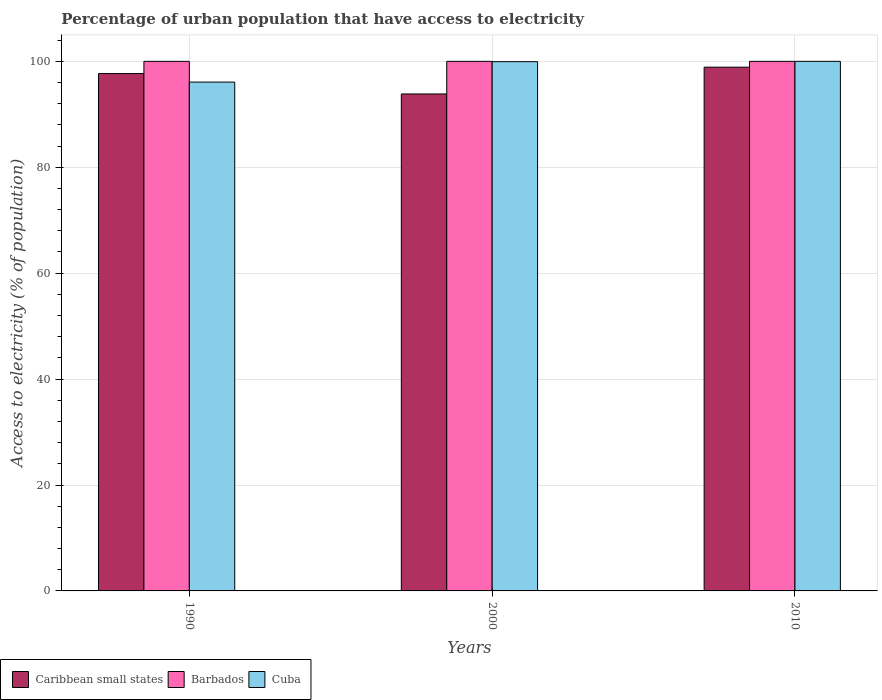How many different coloured bars are there?
Give a very brief answer. 3. Are the number of bars on each tick of the X-axis equal?
Your response must be concise. Yes. How many bars are there on the 1st tick from the left?
Offer a very short reply. 3. What is the label of the 2nd group of bars from the left?
Your response must be concise. 2000. In how many cases, is the number of bars for a given year not equal to the number of legend labels?
Give a very brief answer. 0. What is the percentage of urban population that have access to electricity in Caribbean small states in 2010?
Keep it short and to the point. 98.9. Across all years, what is the maximum percentage of urban population that have access to electricity in Barbados?
Provide a succinct answer. 100. Across all years, what is the minimum percentage of urban population that have access to electricity in Caribbean small states?
Your answer should be very brief. 93.84. In which year was the percentage of urban population that have access to electricity in Caribbean small states maximum?
Give a very brief answer. 2010. What is the total percentage of urban population that have access to electricity in Caribbean small states in the graph?
Provide a succinct answer. 290.44. What is the difference between the percentage of urban population that have access to electricity in Caribbean small states in 2000 and that in 2010?
Ensure brevity in your answer.  -5.06. What is the difference between the percentage of urban population that have access to electricity in Cuba in 2000 and the percentage of urban population that have access to electricity in Caribbean small states in 1990?
Provide a short and direct response. 2.24. What is the average percentage of urban population that have access to electricity in Barbados per year?
Give a very brief answer. 100. In the year 1990, what is the difference between the percentage of urban population that have access to electricity in Barbados and percentage of urban population that have access to electricity in Caribbean small states?
Offer a terse response. 2.3. In how many years, is the percentage of urban population that have access to electricity in Caribbean small states greater than 36 %?
Offer a very short reply. 3. What is the ratio of the percentage of urban population that have access to electricity in Barbados in 1990 to that in 2000?
Your response must be concise. 1. Is the percentage of urban population that have access to electricity in Caribbean small states in 1990 less than that in 2000?
Your answer should be very brief. No. What is the difference between the highest and the second highest percentage of urban population that have access to electricity in Cuba?
Provide a succinct answer. 0.06. What is the difference between the highest and the lowest percentage of urban population that have access to electricity in Cuba?
Offer a terse response. 3.91. In how many years, is the percentage of urban population that have access to electricity in Cuba greater than the average percentage of urban population that have access to electricity in Cuba taken over all years?
Ensure brevity in your answer.  2. Is the sum of the percentage of urban population that have access to electricity in Caribbean small states in 2000 and 2010 greater than the maximum percentage of urban population that have access to electricity in Barbados across all years?
Make the answer very short. Yes. What does the 2nd bar from the left in 2000 represents?
Offer a terse response. Barbados. What does the 3rd bar from the right in 2000 represents?
Your response must be concise. Caribbean small states. Is it the case that in every year, the sum of the percentage of urban population that have access to electricity in Barbados and percentage of urban population that have access to electricity in Caribbean small states is greater than the percentage of urban population that have access to electricity in Cuba?
Your answer should be compact. Yes. How many bars are there?
Offer a very short reply. 9. How many years are there in the graph?
Provide a succinct answer. 3. Does the graph contain any zero values?
Keep it short and to the point. No. Where does the legend appear in the graph?
Your response must be concise. Bottom left. What is the title of the graph?
Your answer should be compact. Percentage of urban population that have access to electricity. What is the label or title of the Y-axis?
Keep it short and to the point. Access to electricity (% of population). What is the Access to electricity (% of population) of Caribbean small states in 1990?
Provide a succinct answer. 97.7. What is the Access to electricity (% of population) in Cuba in 1990?
Your answer should be very brief. 96.09. What is the Access to electricity (% of population) of Caribbean small states in 2000?
Your answer should be compact. 93.84. What is the Access to electricity (% of population) in Barbados in 2000?
Your answer should be compact. 100. What is the Access to electricity (% of population) of Cuba in 2000?
Make the answer very short. 99.94. What is the Access to electricity (% of population) in Caribbean small states in 2010?
Your answer should be very brief. 98.9. What is the Access to electricity (% of population) in Barbados in 2010?
Give a very brief answer. 100. What is the Access to electricity (% of population) in Cuba in 2010?
Keep it short and to the point. 100. Across all years, what is the maximum Access to electricity (% of population) of Caribbean small states?
Ensure brevity in your answer.  98.9. Across all years, what is the maximum Access to electricity (% of population) of Cuba?
Ensure brevity in your answer.  100. Across all years, what is the minimum Access to electricity (% of population) of Caribbean small states?
Give a very brief answer. 93.84. Across all years, what is the minimum Access to electricity (% of population) in Cuba?
Provide a succinct answer. 96.09. What is the total Access to electricity (% of population) in Caribbean small states in the graph?
Make the answer very short. 290.44. What is the total Access to electricity (% of population) of Barbados in the graph?
Your response must be concise. 300. What is the total Access to electricity (% of population) in Cuba in the graph?
Your answer should be very brief. 296.02. What is the difference between the Access to electricity (% of population) in Caribbean small states in 1990 and that in 2000?
Ensure brevity in your answer.  3.85. What is the difference between the Access to electricity (% of population) in Cuba in 1990 and that in 2000?
Ensure brevity in your answer.  -3.85. What is the difference between the Access to electricity (% of population) in Caribbean small states in 1990 and that in 2010?
Your answer should be very brief. -1.2. What is the difference between the Access to electricity (% of population) in Barbados in 1990 and that in 2010?
Give a very brief answer. 0. What is the difference between the Access to electricity (% of population) in Cuba in 1990 and that in 2010?
Provide a succinct answer. -3.91. What is the difference between the Access to electricity (% of population) in Caribbean small states in 2000 and that in 2010?
Ensure brevity in your answer.  -5.06. What is the difference between the Access to electricity (% of population) in Cuba in 2000 and that in 2010?
Provide a succinct answer. -0.06. What is the difference between the Access to electricity (% of population) of Caribbean small states in 1990 and the Access to electricity (% of population) of Barbados in 2000?
Offer a very short reply. -2.3. What is the difference between the Access to electricity (% of population) in Caribbean small states in 1990 and the Access to electricity (% of population) in Cuba in 2000?
Offer a very short reply. -2.24. What is the difference between the Access to electricity (% of population) in Barbados in 1990 and the Access to electricity (% of population) in Cuba in 2000?
Ensure brevity in your answer.  0.06. What is the difference between the Access to electricity (% of population) in Caribbean small states in 1990 and the Access to electricity (% of population) in Barbados in 2010?
Ensure brevity in your answer.  -2.3. What is the difference between the Access to electricity (% of population) in Caribbean small states in 1990 and the Access to electricity (% of population) in Cuba in 2010?
Make the answer very short. -2.3. What is the difference between the Access to electricity (% of population) in Caribbean small states in 2000 and the Access to electricity (% of population) in Barbados in 2010?
Make the answer very short. -6.16. What is the difference between the Access to electricity (% of population) in Caribbean small states in 2000 and the Access to electricity (% of population) in Cuba in 2010?
Offer a terse response. -6.16. What is the average Access to electricity (% of population) of Caribbean small states per year?
Your response must be concise. 96.81. What is the average Access to electricity (% of population) of Barbados per year?
Ensure brevity in your answer.  100. What is the average Access to electricity (% of population) in Cuba per year?
Provide a succinct answer. 98.67. In the year 1990, what is the difference between the Access to electricity (% of population) in Caribbean small states and Access to electricity (% of population) in Barbados?
Keep it short and to the point. -2.3. In the year 1990, what is the difference between the Access to electricity (% of population) of Caribbean small states and Access to electricity (% of population) of Cuba?
Your response must be concise. 1.61. In the year 1990, what is the difference between the Access to electricity (% of population) of Barbados and Access to electricity (% of population) of Cuba?
Give a very brief answer. 3.91. In the year 2000, what is the difference between the Access to electricity (% of population) in Caribbean small states and Access to electricity (% of population) in Barbados?
Your answer should be compact. -6.16. In the year 2000, what is the difference between the Access to electricity (% of population) in Caribbean small states and Access to electricity (% of population) in Cuba?
Give a very brief answer. -6.09. In the year 2000, what is the difference between the Access to electricity (% of population) of Barbados and Access to electricity (% of population) of Cuba?
Offer a very short reply. 0.06. In the year 2010, what is the difference between the Access to electricity (% of population) of Caribbean small states and Access to electricity (% of population) of Barbados?
Give a very brief answer. -1.1. In the year 2010, what is the difference between the Access to electricity (% of population) in Caribbean small states and Access to electricity (% of population) in Cuba?
Your answer should be compact. -1.1. In the year 2010, what is the difference between the Access to electricity (% of population) in Barbados and Access to electricity (% of population) in Cuba?
Ensure brevity in your answer.  0. What is the ratio of the Access to electricity (% of population) of Caribbean small states in 1990 to that in 2000?
Provide a short and direct response. 1.04. What is the ratio of the Access to electricity (% of population) in Barbados in 1990 to that in 2000?
Give a very brief answer. 1. What is the ratio of the Access to electricity (% of population) of Cuba in 1990 to that in 2000?
Offer a terse response. 0.96. What is the ratio of the Access to electricity (% of population) in Cuba in 1990 to that in 2010?
Ensure brevity in your answer.  0.96. What is the ratio of the Access to electricity (% of population) in Caribbean small states in 2000 to that in 2010?
Offer a very short reply. 0.95. What is the ratio of the Access to electricity (% of population) in Barbados in 2000 to that in 2010?
Keep it short and to the point. 1. What is the difference between the highest and the second highest Access to electricity (% of population) in Caribbean small states?
Offer a terse response. 1.2. What is the difference between the highest and the second highest Access to electricity (% of population) of Cuba?
Provide a short and direct response. 0.06. What is the difference between the highest and the lowest Access to electricity (% of population) of Caribbean small states?
Ensure brevity in your answer.  5.06. What is the difference between the highest and the lowest Access to electricity (% of population) in Cuba?
Your answer should be very brief. 3.91. 